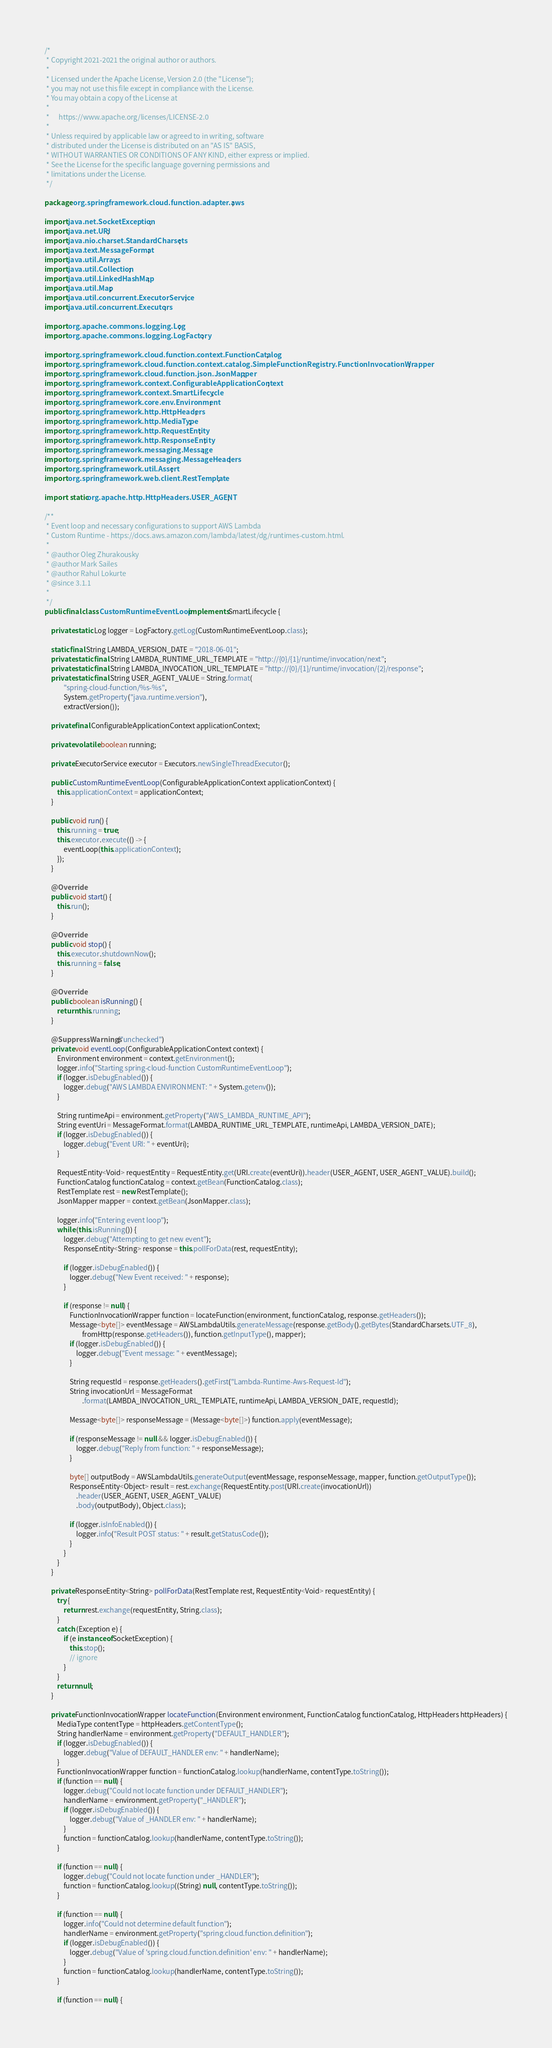Convert code to text. <code><loc_0><loc_0><loc_500><loc_500><_Java_>/*
 * Copyright 2021-2021 the original author or authors.
 *
 * Licensed under the Apache License, Version 2.0 (the "License");
 * you may not use this file except in compliance with the License.
 * You may obtain a copy of the License at
 *
 *      https://www.apache.org/licenses/LICENSE-2.0
 *
 * Unless required by applicable law or agreed to in writing, software
 * distributed under the License is distributed on an "AS IS" BASIS,
 * WITHOUT WARRANTIES OR CONDITIONS OF ANY KIND, either express or implied.
 * See the License for the specific language governing permissions and
 * limitations under the License.
 */

package org.springframework.cloud.function.adapter.aws;

import java.net.SocketException;
import java.net.URI;
import java.nio.charset.StandardCharsets;
import java.text.MessageFormat;
import java.util.Arrays;
import java.util.Collection;
import java.util.LinkedHashMap;
import java.util.Map;
import java.util.concurrent.ExecutorService;
import java.util.concurrent.Executors;

import org.apache.commons.logging.Log;
import org.apache.commons.logging.LogFactory;

import org.springframework.cloud.function.context.FunctionCatalog;
import org.springframework.cloud.function.context.catalog.SimpleFunctionRegistry.FunctionInvocationWrapper;
import org.springframework.cloud.function.json.JsonMapper;
import org.springframework.context.ConfigurableApplicationContext;
import org.springframework.context.SmartLifecycle;
import org.springframework.core.env.Environment;
import org.springframework.http.HttpHeaders;
import org.springframework.http.MediaType;
import org.springframework.http.RequestEntity;
import org.springframework.http.ResponseEntity;
import org.springframework.messaging.Message;
import org.springframework.messaging.MessageHeaders;
import org.springframework.util.Assert;
import org.springframework.web.client.RestTemplate;

import static org.apache.http.HttpHeaders.USER_AGENT;

/**
 * Event loop and necessary configurations to support AWS Lambda
 * Custom Runtime - https://docs.aws.amazon.com/lambda/latest/dg/runtimes-custom.html.
 *
 * @author Oleg Zhurakousky
 * @author Mark Sailes
 * @author Rahul Lokurte
 * @since 3.1.1
 *
 */
public final class CustomRuntimeEventLoop implements SmartLifecycle {

	private static Log logger = LogFactory.getLog(CustomRuntimeEventLoop.class);

	static final String LAMBDA_VERSION_DATE = "2018-06-01";
	private static final String LAMBDA_RUNTIME_URL_TEMPLATE = "http://{0}/{1}/runtime/invocation/next";
	private static final String LAMBDA_INVOCATION_URL_TEMPLATE = "http://{0}/{1}/runtime/invocation/{2}/response";
	private static final String USER_AGENT_VALUE = String.format(
			"spring-cloud-function/%s-%s",
			System.getProperty("java.runtime.version"),
			extractVersion());

	private final ConfigurableApplicationContext applicationContext;

	private volatile boolean running;

	private ExecutorService executor = Executors.newSingleThreadExecutor();

	public CustomRuntimeEventLoop(ConfigurableApplicationContext applicationContext) {
		this.applicationContext = applicationContext;
	}

	public void run() {
		this.running = true;
		this.executor.execute(() -> {
			eventLoop(this.applicationContext);
		});
	}

	@Override
	public void start() {
		this.run();
	}

	@Override
	public void stop() {
		this.executor.shutdownNow();
		this.running = false;
	}

	@Override
	public boolean isRunning() {
		return this.running;
	}

	@SuppressWarnings("unchecked")
	private void eventLoop(ConfigurableApplicationContext context) {
		Environment environment = context.getEnvironment();
		logger.info("Starting spring-cloud-function CustomRuntimeEventLoop");
		if (logger.isDebugEnabled()) {
			logger.debug("AWS LAMBDA ENVIRONMENT: " + System.getenv());
		}

		String runtimeApi = environment.getProperty("AWS_LAMBDA_RUNTIME_API");
		String eventUri = MessageFormat.format(LAMBDA_RUNTIME_URL_TEMPLATE, runtimeApi, LAMBDA_VERSION_DATE);
		if (logger.isDebugEnabled()) {
			logger.debug("Event URI: " + eventUri);
		}

		RequestEntity<Void> requestEntity = RequestEntity.get(URI.create(eventUri)).header(USER_AGENT, USER_AGENT_VALUE).build();
		FunctionCatalog functionCatalog = context.getBean(FunctionCatalog.class);
		RestTemplate rest = new RestTemplate();
		JsonMapper mapper = context.getBean(JsonMapper.class);

		logger.info("Entering event loop");
		while (this.isRunning()) {
			logger.debug("Attempting to get new event");
			ResponseEntity<String> response = this.pollForData(rest, requestEntity);

			if (logger.isDebugEnabled()) {
				logger.debug("New Event received: " + response);
			}

			if (response != null) {
				FunctionInvocationWrapper function = locateFunction(environment, functionCatalog, response.getHeaders());
				Message<byte[]> eventMessage = AWSLambdaUtils.generateMessage(response.getBody().getBytes(StandardCharsets.UTF_8),
						fromHttp(response.getHeaders()), function.getInputType(), mapper);
				if (logger.isDebugEnabled()) {
					logger.debug("Event message: " + eventMessage);
				}

				String requestId = response.getHeaders().getFirst("Lambda-Runtime-Aws-Request-Id");
				String invocationUrl = MessageFormat
						.format(LAMBDA_INVOCATION_URL_TEMPLATE, runtimeApi, LAMBDA_VERSION_DATE, requestId);

				Message<byte[]> responseMessage = (Message<byte[]>) function.apply(eventMessage);

				if (responseMessage != null && logger.isDebugEnabled()) {
					logger.debug("Reply from function: " + responseMessage);
				}

				byte[] outputBody = AWSLambdaUtils.generateOutput(eventMessage, responseMessage, mapper, function.getOutputType());
				ResponseEntity<Object> result = rest.exchange(RequestEntity.post(URI.create(invocationUrl))
					.header(USER_AGENT, USER_AGENT_VALUE)
					.body(outputBody), Object.class);

				if (logger.isInfoEnabled()) {
					logger.info("Result POST status: " + result.getStatusCode());
				}
			}
		}
	}

	private ResponseEntity<String> pollForData(RestTemplate rest, RequestEntity<Void> requestEntity) {
		try {
			return rest.exchange(requestEntity, String.class);
		}
		catch (Exception e) {
			if (e instanceof SocketException) {
				this.stop();
				// ignore
			}
		}
		return null;
	}

	private FunctionInvocationWrapper locateFunction(Environment environment, FunctionCatalog functionCatalog, HttpHeaders httpHeaders) {
		MediaType contentType = httpHeaders.getContentType();
		String handlerName = environment.getProperty("DEFAULT_HANDLER");
		if (logger.isDebugEnabled()) {
			logger.debug("Value of DEFAULT_HANDLER env: " + handlerName);
		}
		FunctionInvocationWrapper function = functionCatalog.lookup(handlerName, contentType.toString());
		if (function == null) {
			logger.debug("Could not locate function under DEFAULT_HANDLER");
			handlerName = environment.getProperty("_HANDLER");
			if (logger.isDebugEnabled()) {
				logger.debug("Value of _HANDLER env: " + handlerName);
			}
			function = functionCatalog.lookup(handlerName, contentType.toString());
		}

		if (function == null) {
			logger.debug("Could not locate function under _HANDLER");
			function = functionCatalog.lookup((String) null, contentType.toString());
		}

		if (function == null) {
			logger.info("Could not determine default function");
			handlerName = environment.getProperty("spring.cloud.function.definition");
			if (logger.isDebugEnabled()) {
				logger.debug("Value of 'spring.cloud.function.definition' env: " + handlerName);
			}
			function = functionCatalog.lookup(handlerName, contentType.toString());
		}

		if (function == null) {</code> 